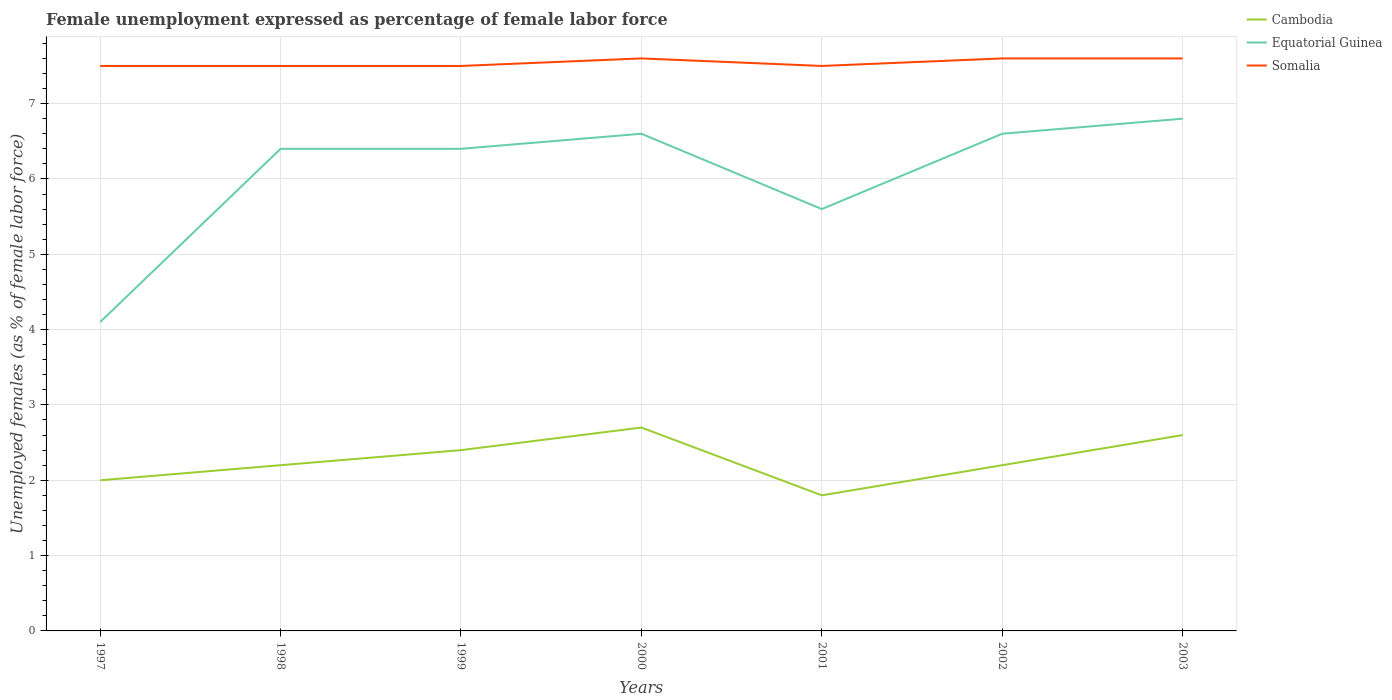Does the line corresponding to Somalia intersect with the line corresponding to Cambodia?
Give a very brief answer. No. Across all years, what is the maximum unemployment in females in in Cambodia?
Your answer should be very brief. 1.8. What is the total unemployment in females in in Somalia in the graph?
Your answer should be compact. -0.1. What is the difference between the highest and the second highest unemployment in females in in Equatorial Guinea?
Keep it short and to the point. 2.7. How many years are there in the graph?
Keep it short and to the point. 7. Are the values on the major ticks of Y-axis written in scientific E-notation?
Keep it short and to the point. No. Does the graph contain grids?
Give a very brief answer. Yes. Where does the legend appear in the graph?
Ensure brevity in your answer.  Top right. How many legend labels are there?
Make the answer very short. 3. What is the title of the graph?
Ensure brevity in your answer.  Female unemployment expressed as percentage of female labor force. Does "Bhutan" appear as one of the legend labels in the graph?
Your answer should be compact. No. What is the label or title of the Y-axis?
Provide a short and direct response. Unemployed females (as % of female labor force). What is the Unemployed females (as % of female labor force) in Equatorial Guinea in 1997?
Provide a succinct answer. 4.1. What is the Unemployed females (as % of female labor force) of Cambodia in 1998?
Give a very brief answer. 2.2. What is the Unemployed females (as % of female labor force) in Equatorial Guinea in 1998?
Keep it short and to the point. 6.4. What is the Unemployed females (as % of female labor force) in Somalia in 1998?
Ensure brevity in your answer.  7.5. What is the Unemployed females (as % of female labor force) in Cambodia in 1999?
Provide a succinct answer. 2.4. What is the Unemployed females (as % of female labor force) in Equatorial Guinea in 1999?
Your answer should be very brief. 6.4. What is the Unemployed females (as % of female labor force) in Somalia in 1999?
Provide a short and direct response. 7.5. What is the Unemployed females (as % of female labor force) in Cambodia in 2000?
Give a very brief answer. 2.7. What is the Unemployed females (as % of female labor force) in Equatorial Guinea in 2000?
Provide a succinct answer. 6.6. What is the Unemployed females (as % of female labor force) of Somalia in 2000?
Make the answer very short. 7.6. What is the Unemployed females (as % of female labor force) of Cambodia in 2001?
Provide a short and direct response. 1.8. What is the Unemployed females (as % of female labor force) in Equatorial Guinea in 2001?
Provide a succinct answer. 5.6. What is the Unemployed females (as % of female labor force) of Somalia in 2001?
Offer a very short reply. 7.5. What is the Unemployed females (as % of female labor force) in Cambodia in 2002?
Provide a short and direct response. 2.2. What is the Unemployed females (as % of female labor force) in Equatorial Guinea in 2002?
Your response must be concise. 6.6. What is the Unemployed females (as % of female labor force) of Somalia in 2002?
Your answer should be very brief. 7.6. What is the Unemployed females (as % of female labor force) in Cambodia in 2003?
Keep it short and to the point. 2.6. What is the Unemployed females (as % of female labor force) of Equatorial Guinea in 2003?
Give a very brief answer. 6.8. What is the Unemployed females (as % of female labor force) in Somalia in 2003?
Make the answer very short. 7.6. Across all years, what is the maximum Unemployed females (as % of female labor force) of Cambodia?
Ensure brevity in your answer.  2.7. Across all years, what is the maximum Unemployed females (as % of female labor force) in Equatorial Guinea?
Provide a succinct answer. 6.8. Across all years, what is the maximum Unemployed females (as % of female labor force) of Somalia?
Your answer should be very brief. 7.6. Across all years, what is the minimum Unemployed females (as % of female labor force) of Cambodia?
Your answer should be compact. 1.8. Across all years, what is the minimum Unemployed females (as % of female labor force) of Equatorial Guinea?
Your answer should be very brief. 4.1. Across all years, what is the minimum Unemployed females (as % of female labor force) of Somalia?
Provide a succinct answer. 7.5. What is the total Unemployed females (as % of female labor force) in Equatorial Guinea in the graph?
Offer a terse response. 42.5. What is the total Unemployed females (as % of female labor force) of Somalia in the graph?
Ensure brevity in your answer.  52.8. What is the difference between the Unemployed females (as % of female labor force) of Somalia in 1997 and that in 1998?
Your answer should be compact. 0. What is the difference between the Unemployed females (as % of female labor force) in Equatorial Guinea in 1997 and that in 1999?
Provide a succinct answer. -2.3. What is the difference between the Unemployed females (as % of female labor force) of Somalia in 1997 and that in 2000?
Your answer should be compact. -0.1. What is the difference between the Unemployed females (as % of female labor force) in Equatorial Guinea in 1997 and that in 2001?
Give a very brief answer. -1.5. What is the difference between the Unemployed females (as % of female labor force) in Somalia in 1997 and that in 2001?
Make the answer very short. 0. What is the difference between the Unemployed females (as % of female labor force) of Equatorial Guinea in 1997 and that in 2003?
Provide a short and direct response. -2.7. What is the difference between the Unemployed females (as % of female labor force) of Cambodia in 1998 and that in 2000?
Provide a succinct answer. -0.5. What is the difference between the Unemployed females (as % of female labor force) in Equatorial Guinea in 1998 and that in 2000?
Ensure brevity in your answer.  -0.2. What is the difference between the Unemployed females (as % of female labor force) of Cambodia in 1998 and that in 2001?
Your answer should be compact. 0.4. What is the difference between the Unemployed females (as % of female labor force) in Equatorial Guinea in 1998 and that in 2001?
Keep it short and to the point. 0.8. What is the difference between the Unemployed females (as % of female labor force) of Cambodia in 1998 and that in 2002?
Keep it short and to the point. 0. What is the difference between the Unemployed females (as % of female labor force) of Somalia in 1998 and that in 2002?
Offer a very short reply. -0.1. What is the difference between the Unemployed females (as % of female labor force) of Cambodia in 1998 and that in 2003?
Provide a short and direct response. -0.4. What is the difference between the Unemployed females (as % of female labor force) of Somalia in 1998 and that in 2003?
Your answer should be very brief. -0.1. What is the difference between the Unemployed females (as % of female labor force) in Cambodia in 1999 and that in 2002?
Your answer should be very brief. 0.2. What is the difference between the Unemployed females (as % of female labor force) of Somalia in 1999 and that in 2002?
Offer a terse response. -0.1. What is the difference between the Unemployed females (as % of female labor force) of Cambodia in 1999 and that in 2003?
Give a very brief answer. -0.2. What is the difference between the Unemployed females (as % of female labor force) in Cambodia in 2000 and that in 2001?
Ensure brevity in your answer.  0.9. What is the difference between the Unemployed females (as % of female labor force) of Equatorial Guinea in 2000 and that in 2001?
Offer a very short reply. 1. What is the difference between the Unemployed females (as % of female labor force) of Somalia in 2000 and that in 2001?
Make the answer very short. 0.1. What is the difference between the Unemployed females (as % of female labor force) in Equatorial Guinea in 2000 and that in 2002?
Keep it short and to the point. 0. What is the difference between the Unemployed females (as % of female labor force) in Somalia in 2000 and that in 2002?
Ensure brevity in your answer.  0. What is the difference between the Unemployed females (as % of female labor force) in Cambodia in 2000 and that in 2003?
Ensure brevity in your answer.  0.1. What is the difference between the Unemployed females (as % of female labor force) of Somalia in 2000 and that in 2003?
Make the answer very short. 0. What is the difference between the Unemployed females (as % of female labor force) of Equatorial Guinea in 2001 and that in 2003?
Your answer should be very brief. -1.2. What is the difference between the Unemployed females (as % of female labor force) in Cambodia in 2002 and that in 2003?
Keep it short and to the point. -0.4. What is the difference between the Unemployed females (as % of female labor force) in Cambodia in 1997 and the Unemployed females (as % of female labor force) in Somalia in 1998?
Provide a succinct answer. -5.5. What is the difference between the Unemployed females (as % of female labor force) in Equatorial Guinea in 1997 and the Unemployed females (as % of female labor force) in Somalia in 1998?
Offer a terse response. -3.4. What is the difference between the Unemployed females (as % of female labor force) of Cambodia in 1997 and the Unemployed females (as % of female labor force) of Equatorial Guinea in 1999?
Ensure brevity in your answer.  -4.4. What is the difference between the Unemployed females (as % of female labor force) of Cambodia in 1997 and the Unemployed females (as % of female labor force) of Somalia in 1999?
Offer a terse response. -5.5. What is the difference between the Unemployed females (as % of female labor force) of Equatorial Guinea in 1997 and the Unemployed females (as % of female labor force) of Somalia in 2000?
Offer a very short reply. -3.5. What is the difference between the Unemployed females (as % of female labor force) in Equatorial Guinea in 1997 and the Unemployed females (as % of female labor force) in Somalia in 2001?
Your answer should be compact. -3.4. What is the difference between the Unemployed females (as % of female labor force) in Equatorial Guinea in 1997 and the Unemployed females (as % of female labor force) in Somalia in 2002?
Provide a short and direct response. -3.5. What is the difference between the Unemployed females (as % of female labor force) of Cambodia in 1997 and the Unemployed females (as % of female labor force) of Equatorial Guinea in 2003?
Your response must be concise. -4.8. What is the difference between the Unemployed females (as % of female labor force) in Cambodia in 1997 and the Unemployed females (as % of female labor force) in Somalia in 2003?
Offer a very short reply. -5.6. What is the difference between the Unemployed females (as % of female labor force) of Equatorial Guinea in 1997 and the Unemployed females (as % of female labor force) of Somalia in 2003?
Ensure brevity in your answer.  -3.5. What is the difference between the Unemployed females (as % of female labor force) of Cambodia in 1998 and the Unemployed females (as % of female labor force) of Somalia in 2000?
Your response must be concise. -5.4. What is the difference between the Unemployed females (as % of female labor force) in Cambodia in 1998 and the Unemployed females (as % of female labor force) in Somalia in 2001?
Your answer should be compact. -5.3. What is the difference between the Unemployed females (as % of female labor force) in Equatorial Guinea in 1998 and the Unemployed females (as % of female labor force) in Somalia in 2001?
Your response must be concise. -1.1. What is the difference between the Unemployed females (as % of female labor force) of Equatorial Guinea in 1998 and the Unemployed females (as % of female labor force) of Somalia in 2002?
Your answer should be very brief. -1.2. What is the difference between the Unemployed females (as % of female labor force) in Cambodia in 1998 and the Unemployed females (as % of female labor force) in Equatorial Guinea in 2003?
Provide a short and direct response. -4.6. What is the difference between the Unemployed females (as % of female labor force) of Cambodia in 1998 and the Unemployed females (as % of female labor force) of Somalia in 2003?
Your answer should be compact. -5.4. What is the difference between the Unemployed females (as % of female labor force) of Cambodia in 1999 and the Unemployed females (as % of female labor force) of Equatorial Guinea in 2000?
Offer a very short reply. -4.2. What is the difference between the Unemployed females (as % of female labor force) of Cambodia in 1999 and the Unemployed females (as % of female labor force) of Somalia in 2000?
Provide a short and direct response. -5.2. What is the difference between the Unemployed females (as % of female labor force) of Equatorial Guinea in 1999 and the Unemployed females (as % of female labor force) of Somalia in 2000?
Offer a terse response. -1.2. What is the difference between the Unemployed females (as % of female labor force) in Cambodia in 1999 and the Unemployed females (as % of female labor force) in Equatorial Guinea in 2001?
Offer a terse response. -3.2. What is the difference between the Unemployed females (as % of female labor force) of Equatorial Guinea in 1999 and the Unemployed females (as % of female labor force) of Somalia in 2001?
Offer a very short reply. -1.1. What is the difference between the Unemployed females (as % of female labor force) in Cambodia in 1999 and the Unemployed females (as % of female labor force) in Somalia in 2002?
Offer a very short reply. -5.2. What is the difference between the Unemployed females (as % of female labor force) in Cambodia in 1999 and the Unemployed females (as % of female labor force) in Equatorial Guinea in 2003?
Keep it short and to the point. -4.4. What is the difference between the Unemployed females (as % of female labor force) in Cambodia in 1999 and the Unemployed females (as % of female labor force) in Somalia in 2003?
Your answer should be very brief. -5.2. What is the difference between the Unemployed females (as % of female labor force) in Cambodia in 2000 and the Unemployed females (as % of female labor force) in Somalia in 2001?
Give a very brief answer. -4.8. What is the difference between the Unemployed females (as % of female labor force) in Equatorial Guinea in 2000 and the Unemployed females (as % of female labor force) in Somalia in 2001?
Ensure brevity in your answer.  -0.9. What is the difference between the Unemployed females (as % of female labor force) in Cambodia in 2000 and the Unemployed females (as % of female labor force) in Equatorial Guinea in 2003?
Provide a succinct answer. -4.1. What is the difference between the Unemployed females (as % of female labor force) in Cambodia in 2001 and the Unemployed females (as % of female labor force) in Equatorial Guinea in 2003?
Your response must be concise. -5. What is the difference between the Unemployed females (as % of female labor force) of Cambodia in 2001 and the Unemployed females (as % of female labor force) of Somalia in 2003?
Ensure brevity in your answer.  -5.8. What is the difference between the Unemployed females (as % of female labor force) in Equatorial Guinea in 2001 and the Unemployed females (as % of female labor force) in Somalia in 2003?
Give a very brief answer. -2. What is the difference between the Unemployed females (as % of female labor force) in Cambodia in 2002 and the Unemployed females (as % of female labor force) in Somalia in 2003?
Offer a very short reply. -5.4. What is the average Unemployed females (as % of female labor force) of Cambodia per year?
Ensure brevity in your answer.  2.27. What is the average Unemployed females (as % of female labor force) of Equatorial Guinea per year?
Provide a succinct answer. 6.07. What is the average Unemployed females (as % of female labor force) of Somalia per year?
Your answer should be compact. 7.54. In the year 1997, what is the difference between the Unemployed females (as % of female labor force) in Cambodia and Unemployed females (as % of female labor force) in Somalia?
Provide a short and direct response. -5.5. In the year 1998, what is the difference between the Unemployed females (as % of female labor force) of Cambodia and Unemployed females (as % of female labor force) of Somalia?
Your response must be concise. -5.3. In the year 1999, what is the difference between the Unemployed females (as % of female labor force) in Equatorial Guinea and Unemployed females (as % of female labor force) in Somalia?
Offer a terse response. -1.1. In the year 2000, what is the difference between the Unemployed females (as % of female labor force) of Cambodia and Unemployed females (as % of female labor force) of Somalia?
Provide a short and direct response. -4.9. In the year 2001, what is the difference between the Unemployed females (as % of female labor force) of Cambodia and Unemployed females (as % of female labor force) of Equatorial Guinea?
Offer a terse response. -3.8. In the year 2002, what is the difference between the Unemployed females (as % of female labor force) of Cambodia and Unemployed females (as % of female labor force) of Equatorial Guinea?
Keep it short and to the point. -4.4. In the year 2003, what is the difference between the Unemployed females (as % of female labor force) in Cambodia and Unemployed females (as % of female labor force) in Equatorial Guinea?
Keep it short and to the point. -4.2. In the year 2003, what is the difference between the Unemployed females (as % of female labor force) in Equatorial Guinea and Unemployed females (as % of female labor force) in Somalia?
Offer a terse response. -0.8. What is the ratio of the Unemployed females (as % of female labor force) of Cambodia in 1997 to that in 1998?
Your answer should be very brief. 0.91. What is the ratio of the Unemployed females (as % of female labor force) in Equatorial Guinea in 1997 to that in 1998?
Make the answer very short. 0.64. What is the ratio of the Unemployed females (as % of female labor force) in Somalia in 1997 to that in 1998?
Give a very brief answer. 1. What is the ratio of the Unemployed females (as % of female labor force) of Equatorial Guinea in 1997 to that in 1999?
Offer a very short reply. 0.64. What is the ratio of the Unemployed females (as % of female labor force) of Somalia in 1997 to that in 1999?
Give a very brief answer. 1. What is the ratio of the Unemployed females (as % of female labor force) in Cambodia in 1997 to that in 2000?
Give a very brief answer. 0.74. What is the ratio of the Unemployed females (as % of female labor force) of Equatorial Guinea in 1997 to that in 2000?
Offer a very short reply. 0.62. What is the ratio of the Unemployed females (as % of female labor force) in Cambodia in 1997 to that in 2001?
Provide a succinct answer. 1.11. What is the ratio of the Unemployed females (as % of female labor force) of Equatorial Guinea in 1997 to that in 2001?
Your answer should be compact. 0.73. What is the ratio of the Unemployed females (as % of female labor force) in Somalia in 1997 to that in 2001?
Your response must be concise. 1. What is the ratio of the Unemployed females (as % of female labor force) in Equatorial Guinea in 1997 to that in 2002?
Your answer should be compact. 0.62. What is the ratio of the Unemployed females (as % of female labor force) of Cambodia in 1997 to that in 2003?
Give a very brief answer. 0.77. What is the ratio of the Unemployed females (as % of female labor force) in Equatorial Guinea in 1997 to that in 2003?
Your response must be concise. 0.6. What is the ratio of the Unemployed females (as % of female labor force) of Cambodia in 1998 to that in 1999?
Your answer should be compact. 0.92. What is the ratio of the Unemployed females (as % of female labor force) in Somalia in 1998 to that in 1999?
Provide a succinct answer. 1. What is the ratio of the Unemployed females (as % of female labor force) in Cambodia in 1998 to that in 2000?
Provide a succinct answer. 0.81. What is the ratio of the Unemployed females (as % of female labor force) in Equatorial Guinea in 1998 to that in 2000?
Provide a short and direct response. 0.97. What is the ratio of the Unemployed females (as % of female labor force) of Somalia in 1998 to that in 2000?
Make the answer very short. 0.99. What is the ratio of the Unemployed females (as % of female labor force) of Cambodia in 1998 to that in 2001?
Your answer should be compact. 1.22. What is the ratio of the Unemployed females (as % of female labor force) in Equatorial Guinea in 1998 to that in 2001?
Provide a short and direct response. 1.14. What is the ratio of the Unemployed females (as % of female labor force) of Somalia in 1998 to that in 2001?
Offer a very short reply. 1. What is the ratio of the Unemployed females (as % of female labor force) in Cambodia in 1998 to that in 2002?
Offer a very short reply. 1. What is the ratio of the Unemployed females (as % of female labor force) in Equatorial Guinea in 1998 to that in 2002?
Your response must be concise. 0.97. What is the ratio of the Unemployed females (as % of female labor force) of Cambodia in 1998 to that in 2003?
Offer a terse response. 0.85. What is the ratio of the Unemployed females (as % of female labor force) of Equatorial Guinea in 1998 to that in 2003?
Provide a short and direct response. 0.94. What is the ratio of the Unemployed females (as % of female labor force) of Cambodia in 1999 to that in 2000?
Keep it short and to the point. 0.89. What is the ratio of the Unemployed females (as % of female labor force) in Equatorial Guinea in 1999 to that in 2000?
Keep it short and to the point. 0.97. What is the ratio of the Unemployed females (as % of female labor force) in Somalia in 1999 to that in 2000?
Your response must be concise. 0.99. What is the ratio of the Unemployed females (as % of female labor force) of Equatorial Guinea in 1999 to that in 2001?
Provide a short and direct response. 1.14. What is the ratio of the Unemployed females (as % of female labor force) in Cambodia in 1999 to that in 2002?
Provide a short and direct response. 1.09. What is the ratio of the Unemployed females (as % of female labor force) in Equatorial Guinea in 1999 to that in 2002?
Ensure brevity in your answer.  0.97. What is the ratio of the Unemployed females (as % of female labor force) of Cambodia in 1999 to that in 2003?
Ensure brevity in your answer.  0.92. What is the ratio of the Unemployed females (as % of female labor force) of Somalia in 1999 to that in 2003?
Keep it short and to the point. 0.99. What is the ratio of the Unemployed females (as % of female labor force) of Cambodia in 2000 to that in 2001?
Make the answer very short. 1.5. What is the ratio of the Unemployed females (as % of female labor force) of Equatorial Guinea in 2000 to that in 2001?
Make the answer very short. 1.18. What is the ratio of the Unemployed females (as % of female labor force) in Somalia in 2000 to that in 2001?
Give a very brief answer. 1.01. What is the ratio of the Unemployed females (as % of female labor force) of Cambodia in 2000 to that in 2002?
Offer a terse response. 1.23. What is the ratio of the Unemployed females (as % of female labor force) of Somalia in 2000 to that in 2002?
Your answer should be compact. 1. What is the ratio of the Unemployed females (as % of female labor force) of Equatorial Guinea in 2000 to that in 2003?
Offer a very short reply. 0.97. What is the ratio of the Unemployed females (as % of female labor force) in Somalia in 2000 to that in 2003?
Your response must be concise. 1. What is the ratio of the Unemployed females (as % of female labor force) of Cambodia in 2001 to that in 2002?
Your response must be concise. 0.82. What is the ratio of the Unemployed females (as % of female labor force) in Equatorial Guinea in 2001 to that in 2002?
Provide a short and direct response. 0.85. What is the ratio of the Unemployed females (as % of female labor force) in Cambodia in 2001 to that in 2003?
Your response must be concise. 0.69. What is the ratio of the Unemployed females (as % of female labor force) of Equatorial Guinea in 2001 to that in 2003?
Keep it short and to the point. 0.82. What is the ratio of the Unemployed females (as % of female labor force) in Somalia in 2001 to that in 2003?
Your answer should be compact. 0.99. What is the ratio of the Unemployed females (as % of female labor force) of Cambodia in 2002 to that in 2003?
Offer a very short reply. 0.85. What is the ratio of the Unemployed females (as % of female labor force) of Equatorial Guinea in 2002 to that in 2003?
Keep it short and to the point. 0.97. What is the difference between the highest and the second highest Unemployed females (as % of female labor force) in Somalia?
Your response must be concise. 0. What is the difference between the highest and the lowest Unemployed females (as % of female labor force) in Cambodia?
Your answer should be very brief. 0.9. What is the difference between the highest and the lowest Unemployed females (as % of female labor force) in Equatorial Guinea?
Ensure brevity in your answer.  2.7. 